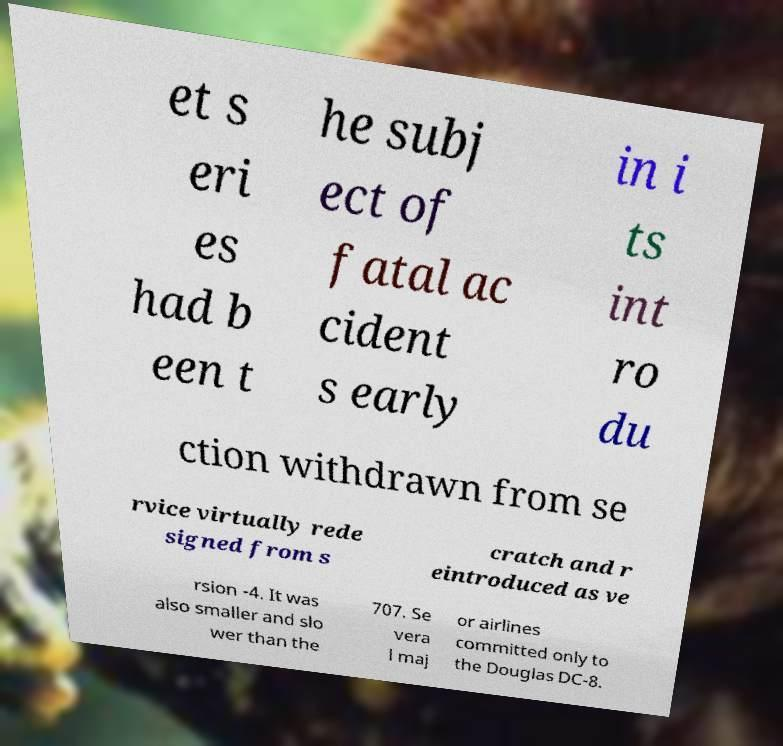Can you accurately transcribe the text from the provided image for me? et s eri es had b een t he subj ect of fatal ac cident s early in i ts int ro du ction withdrawn from se rvice virtually rede signed from s cratch and r eintroduced as ve rsion -4. It was also smaller and slo wer than the 707. Se vera l maj or airlines committed only to the Douglas DC-8. 